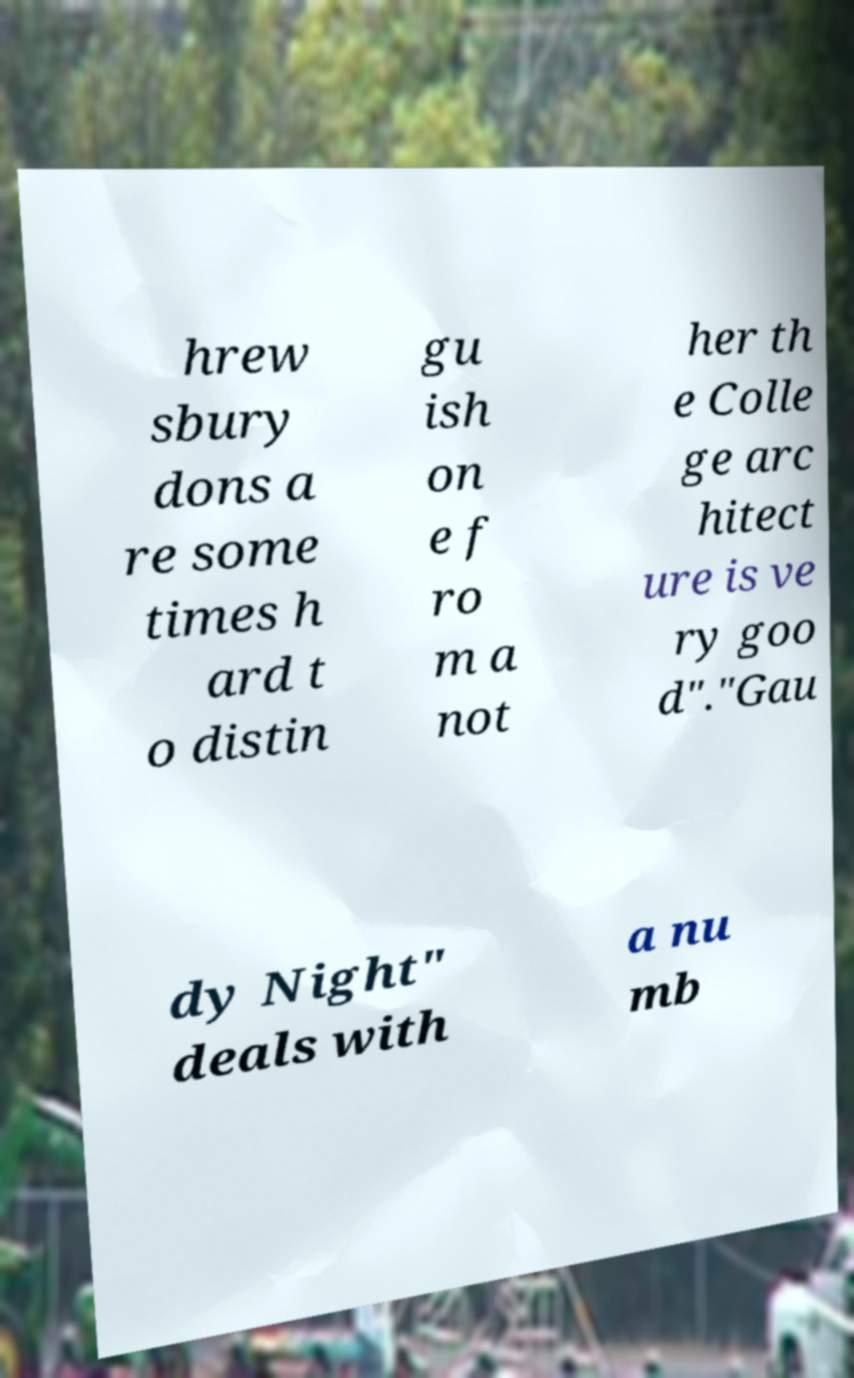Please read and relay the text visible in this image. What does it say? hrew sbury dons a re some times h ard t o distin gu ish on e f ro m a not her th e Colle ge arc hitect ure is ve ry goo d"."Gau dy Night" deals with a nu mb 